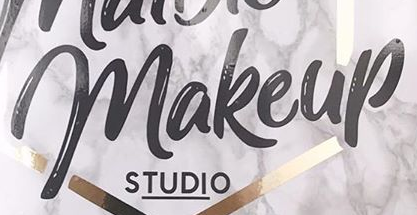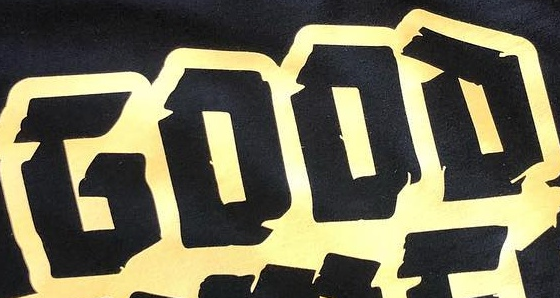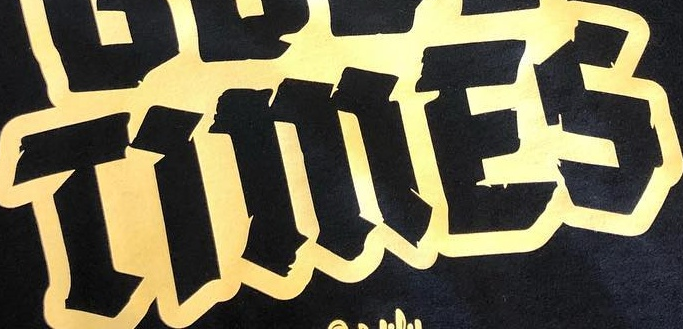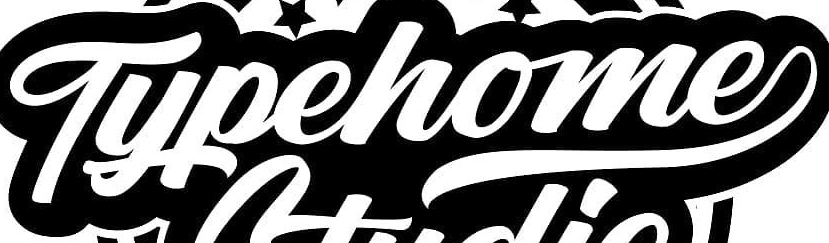What text appears in these images from left to right, separated by a semicolon? makeup; GOOD; TiMES; Typehome 